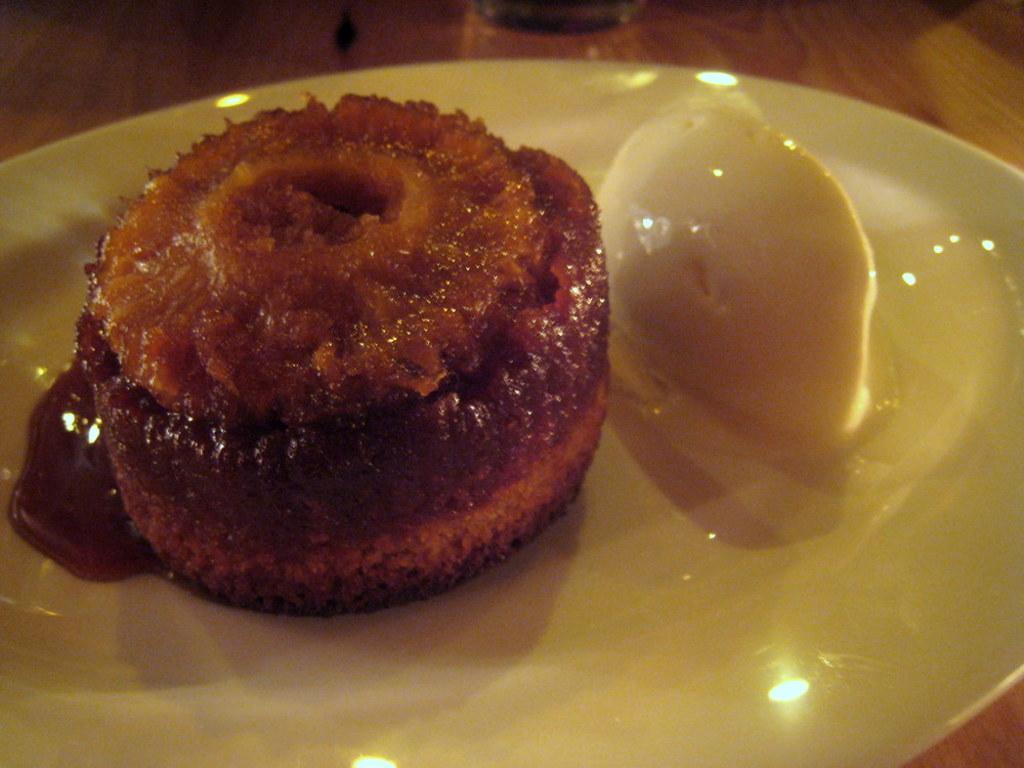Describe this image in one or two sentences. In this image I can see a white colored plate on the brown colored table and on the plate I can see a pudding which is white in color and a food item which is brown in color and on the table I can see a glass. 